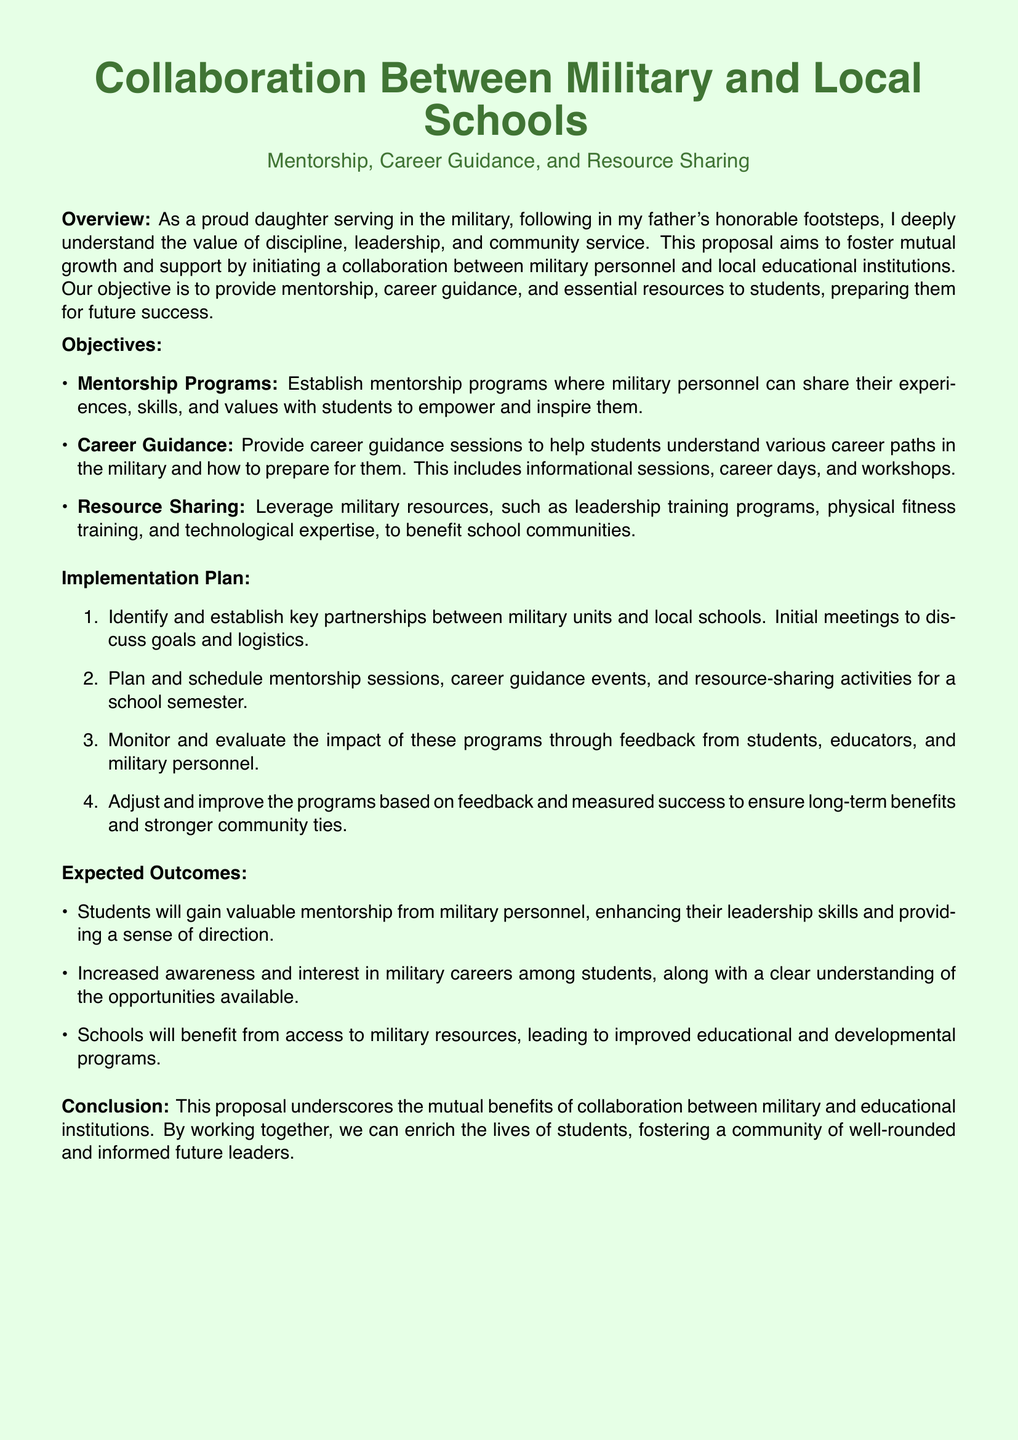What is the proposal's main focus? The main focus of the proposal is to foster relationships between military personnel and educational institutions.
Answer: fostering relationships between military personnel and educational institutions What are the three main objectives listed? The proposal lists mentorship programs, career guidance, and resource sharing as the three main objectives.
Answer: mentorship programs, career guidance, resource sharing How many steps are included in the implementation plan? The implementation plan consists of four steps detailed in the document.
Answer: four What is the expected outcome for students regarding mentorship? The expected outcome is that students will gain valuable mentorship from military personnel.
Answer: gain valuable mentorship Who benefits from access to military resources according to the expected outcomes? Schools benefit from access to military resources, leading to improved educational and developmental programs.
Answer: Schools 